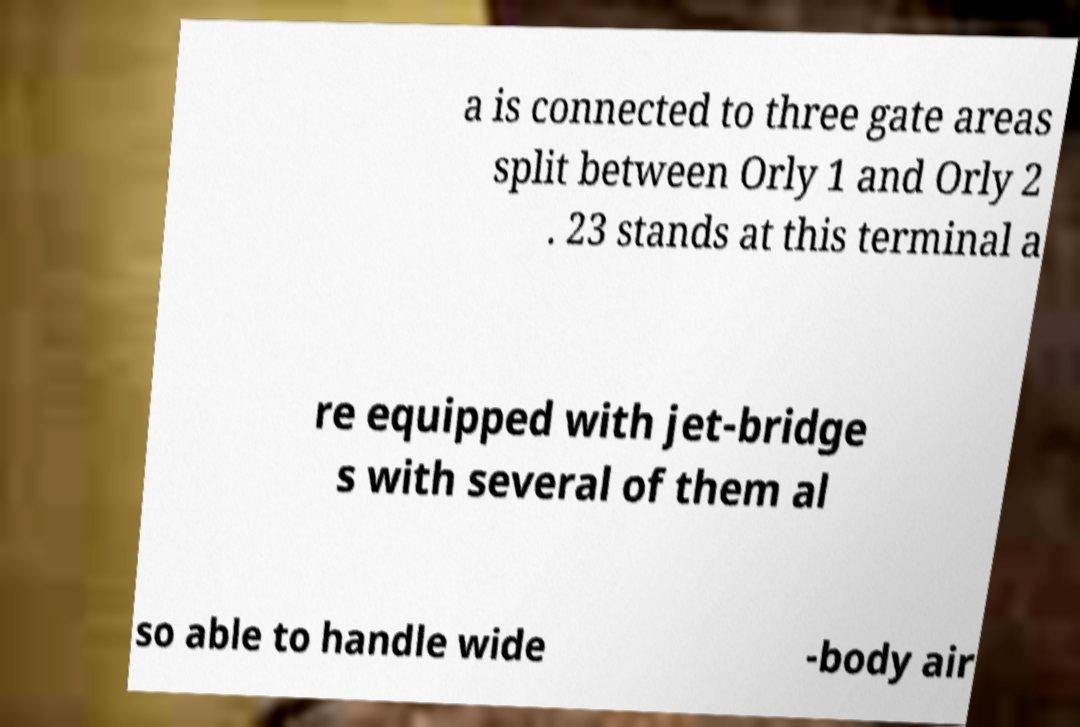For documentation purposes, I need the text within this image transcribed. Could you provide that? a is connected to three gate areas split between Orly 1 and Orly 2 . 23 stands at this terminal a re equipped with jet-bridge s with several of them al so able to handle wide -body air 